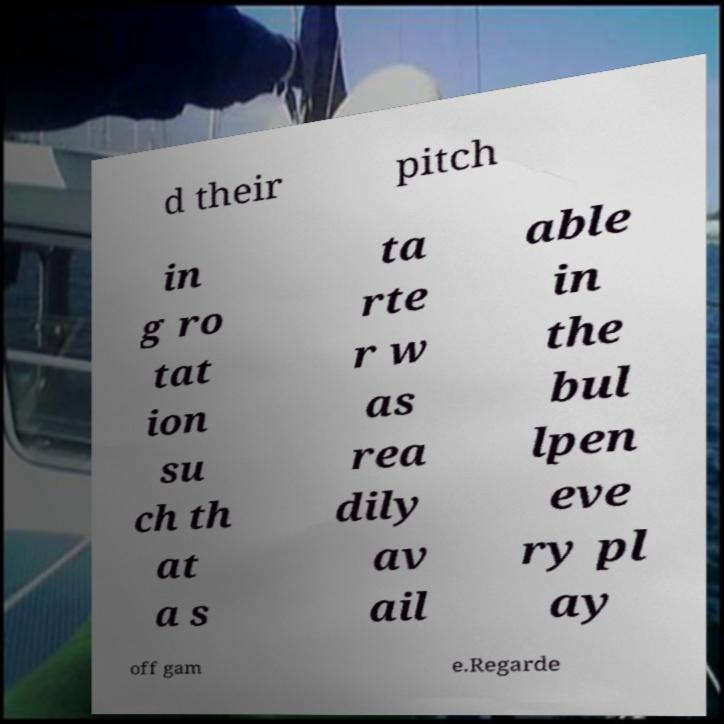What messages or text are displayed in this image? I need them in a readable, typed format. d their pitch in g ro tat ion su ch th at a s ta rte r w as rea dily av ail able in the bul lpen eve ry pl ay off gam e.Regarde 